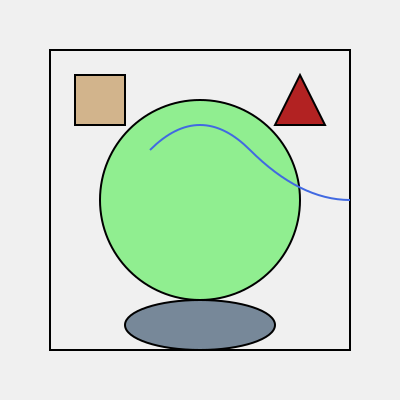In this traditional Japanese tea garden layout, which element represents the koi pond, and what is its position relative to the other garden features? To answer this question, let's analyze the elements in the tea garden layout:

1. The large green circle in the center represents the main grass area.
2. The blue curved line represents a winding path.
3. The brown square in the top-left corner represents a tea house.
4. The red triangle in the top-right corner represents a decorative lantern.
5. The grey oval at the bottom represents the koi pond.

In traditional Japanese garden design, koi ponds are often placed in a lower area of the garden to symbolize the flow of water from mountains to the sea. This is reflected in the layout, where the koi pond (grey oval) is positioned at the bottom of the diagram.

Relative to other features:
- The koi pond is below the main grass area.
- It is at the end of the winding path.
- It is diagonally opposite to the tea house.
- It is directly below the decorative lantern.

This arrangement creates a harmonious balance in the garden, allowing visitors to appreciate each element as they follow the path from the tea house to the pond.
Answer: The grey oval at the bottom 